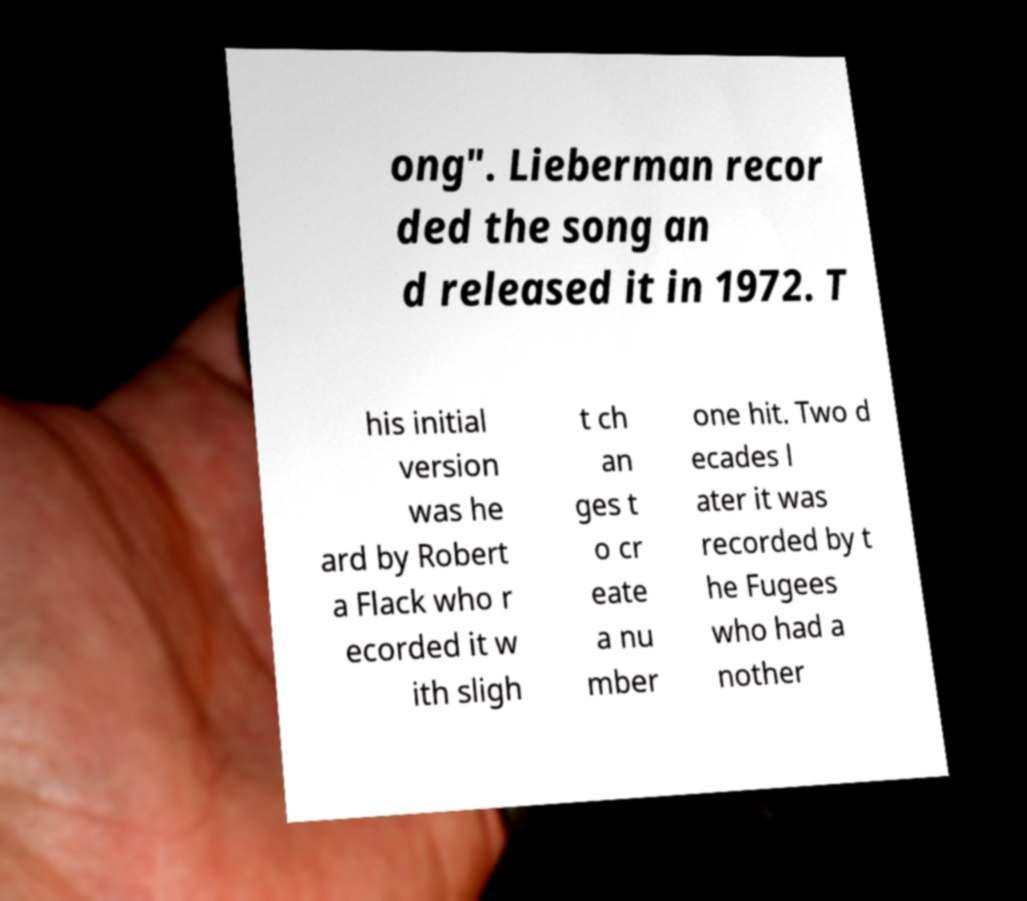For documentation purposes, I need the text within this image transcribed. Could you provide that? ong". Lieberman recor ded the song an d released it in 1972. T his initial version was he ard by Robert a Flack who r ecorded it w ith sligh t ch an ges t o cr eate a nu mber one hit. Two d ecades l ater it was recorded by t he Fugees who had a nother 